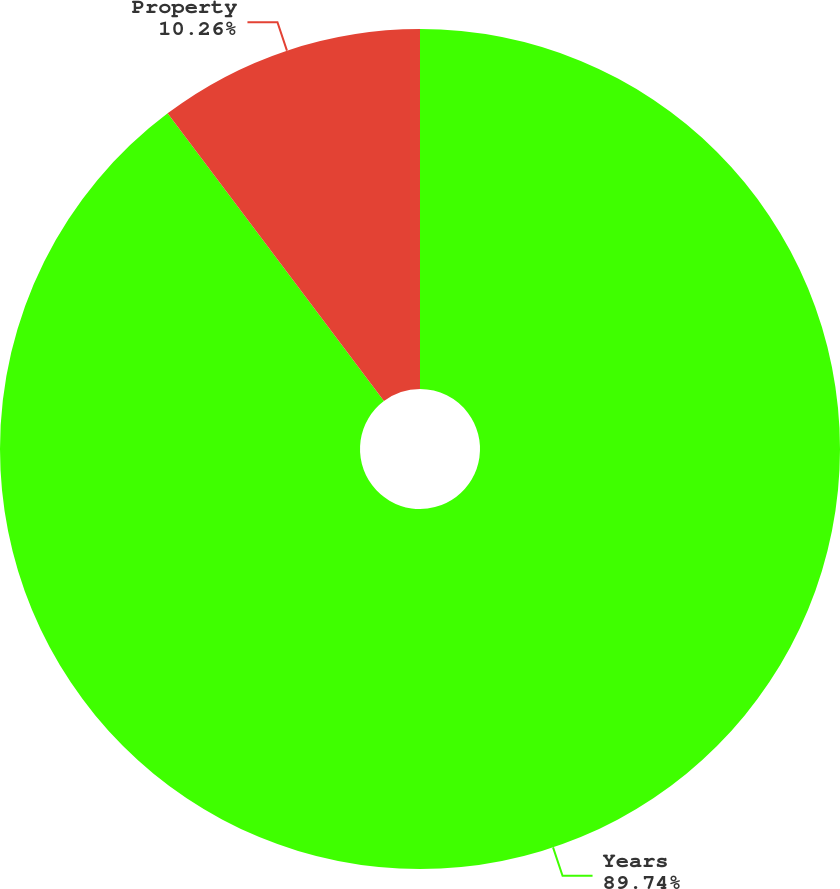Convert chart. <chart><loc_0><loc_0><loc_500><loc_500><pie_chart><fcel>Years<fcel>Property<nl><fcel>89.74%<fcel>10.26%<nl></chart> 